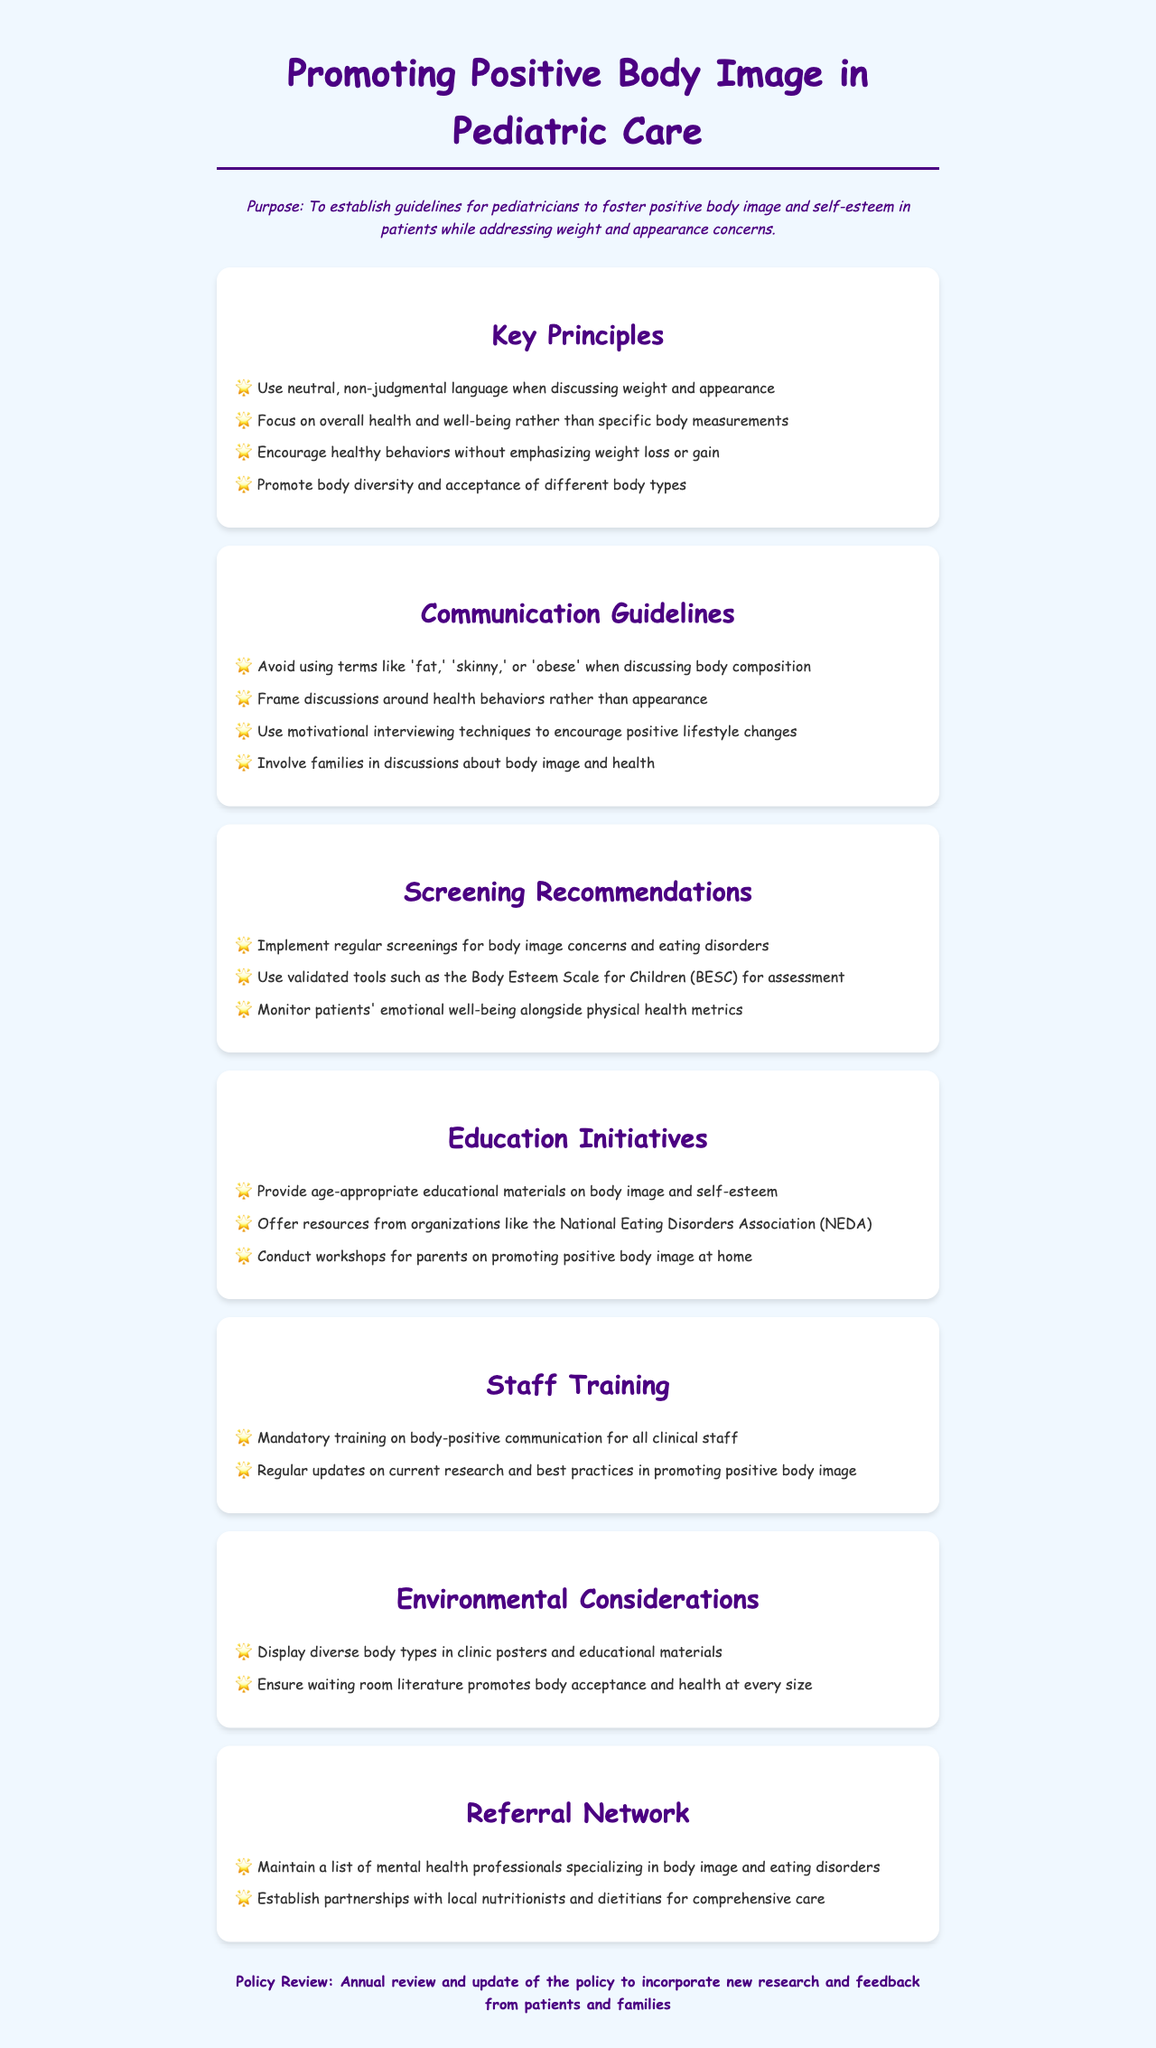What is the purpose of the policy? The purpose is to establish guidelines for pediatricians to foster positive body image and self-esteem in patients while addressing weight and appearance concerns.
Answer: To establish guidelines for pediatricians to foster positive body image and self-esteem in patients while addressing weight and appearance concerns What does the policy recommend regarding language use when discussing body image? The policy recommends using neutral, non-judgmental language when discussing weight and appearance.
Answer: Use neutral, non-judgmental language What should discussions focus on instead of specific body measurements? The policy states that discussions should focus on overall health and well-being.
Answer: Overall health and well-being What is one strategy to encourage positive lifestyle changes? The policy suggests using motivational interviewing techniques.
Answer: Use motivational interviewing techniques What type of materials should be provided to educate children about body image? The policy calls for age-appropriate educational materials on body image and self-esteem.
Answer: Age-appropriate educational materials How often should the policy be reviewed? According to the policy, it should be reviewed annually.
Answer: Annual What is one type of screening recommended by the policy? The policy recommends implementing regular screenings for body image concerns and eating disorders.
Answer: Regular screenings for body image concerns and eating disorders What should be displayed in clinic posters according to the environmental considerations? The policy indicates that diverse body types should be displayed.
Answer: Diverse body types 